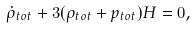Convert formula to latex. <formula><loc_0><loc_0><loc_500><loc_500>\dot { \rho } _ { t o t } + 3 ( \rho _ { t o t } + p _ { t o t } ) H = 0 ,</formula> 